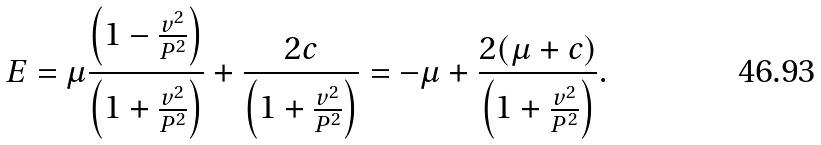<formula> <loc_0><loc_0><loc_500><loc_500>E = \mu \frac { \left ( 1 - \frac { v ^ { 2 } } { P ^ { 2 } } \right ) } { \left ( 1 + \frac { v ^ { 2 } } { P ^ { 2 } } \right ) } + \frac { 2 c } { \left ( 1 + \frac { v ^ { 2 } } { P ^ { 2 } } \right ) } = - \mu + \frac { 2 ( \mu + c ) } { \left ( 1 + \frac { v ^ { 2 } } { P ^ { 2 } } \right ) } .</formula> 